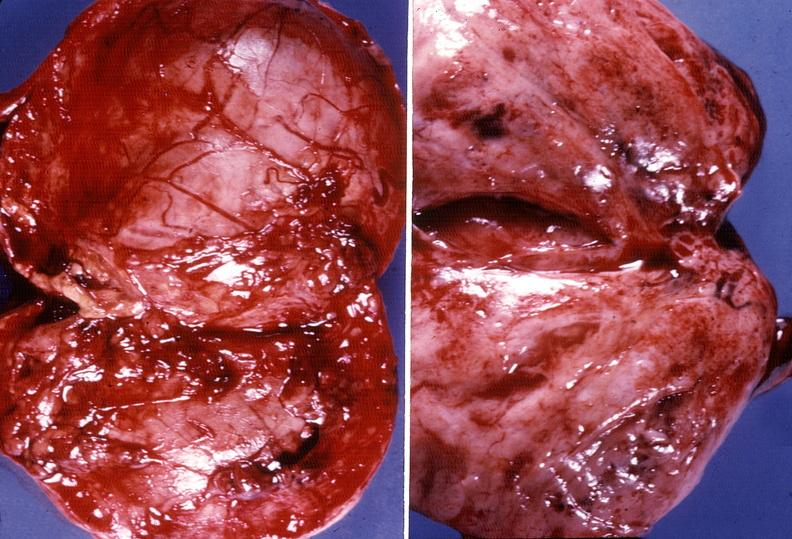s fat necrosis present?
Answer the question using a single word or phrase. No 